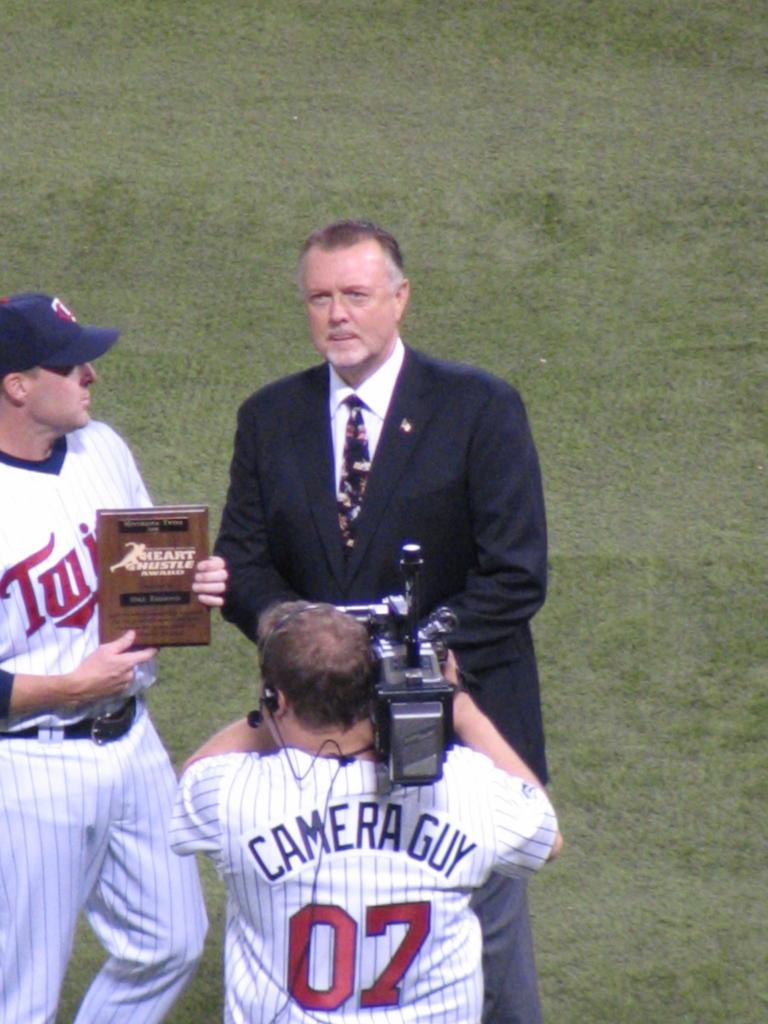<image>
Write a terse but informative summary of the picture. A camera guy has a sports jersey that says "Camera Guy" on the back. 